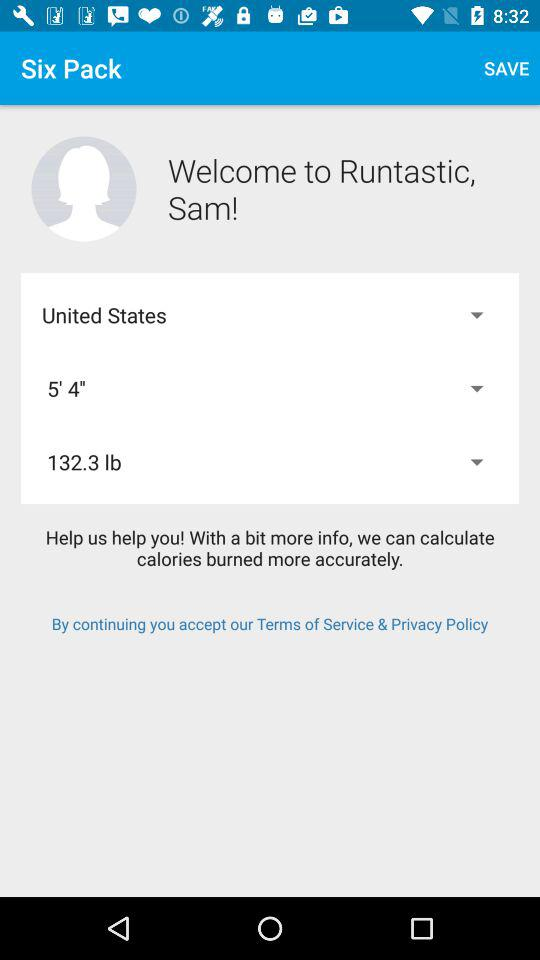Which country is selected? The selected country is the United States. 